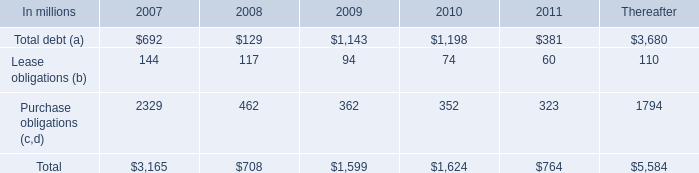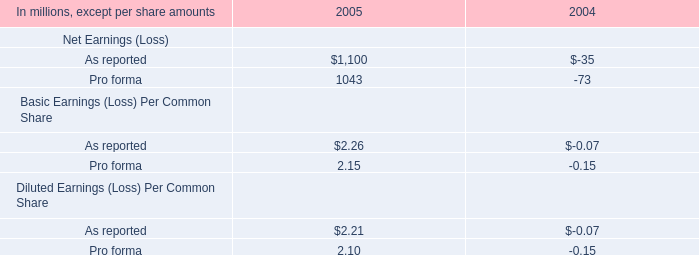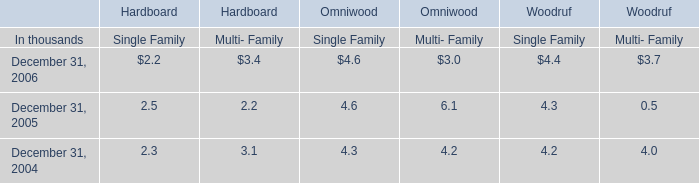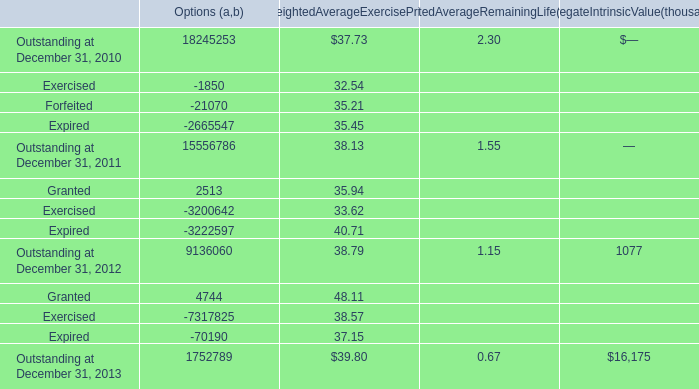what was the percentage of total debt associated with lease obligations related to discontinued operations and businesses held for sale due in 2007 
Computations: (23 / 2329)
Answer: 0.00988. 